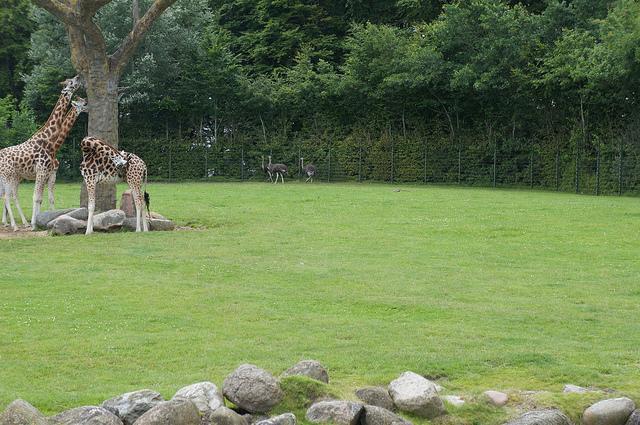How many giraffes are in the photo?
Give a very brief answer. 2. 